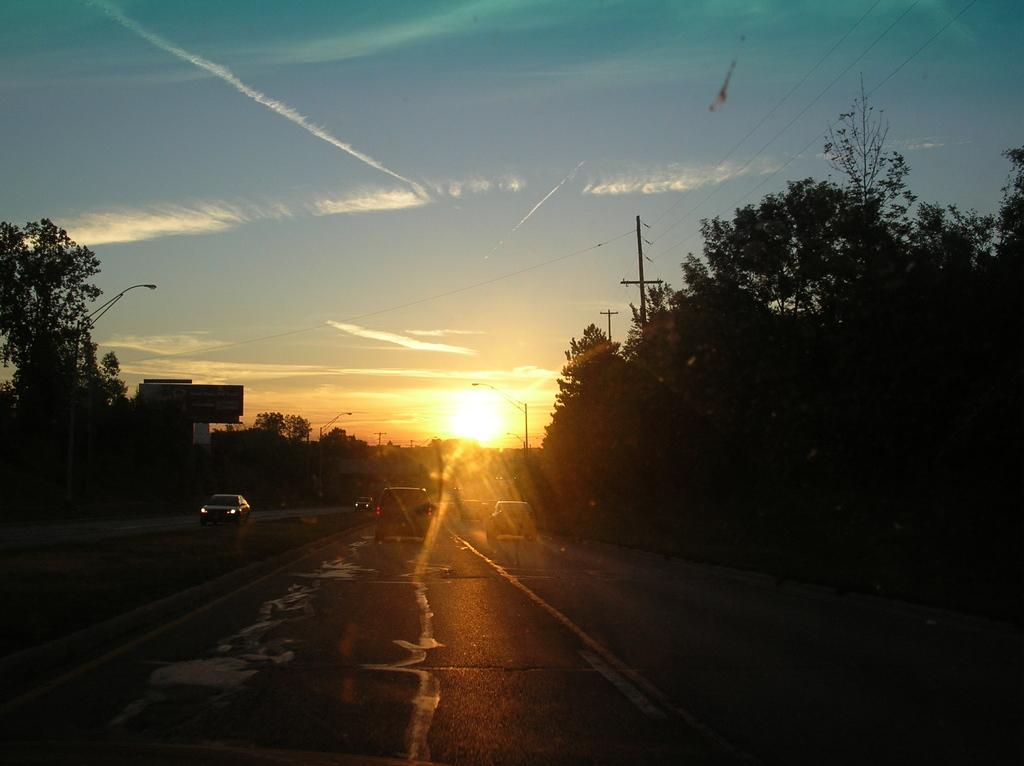What can be seen on the roads in the image? There are vehicles on the roads in the image. What feature do the roads have? The roads have dividers in the image. What type of vegetation is present alongside the roads? There are trees on both sides of the dividers in the image. What is visible in the background of the image? The sun is visible in the background, and there are clouds in the sky. What type of quiver can be seen in the image? There is no quiver present in the image. What kind of observation is being conducted in the image? There is no observation being conducted in the image; it is a scene of vehicles on roads with dividers and trees. 